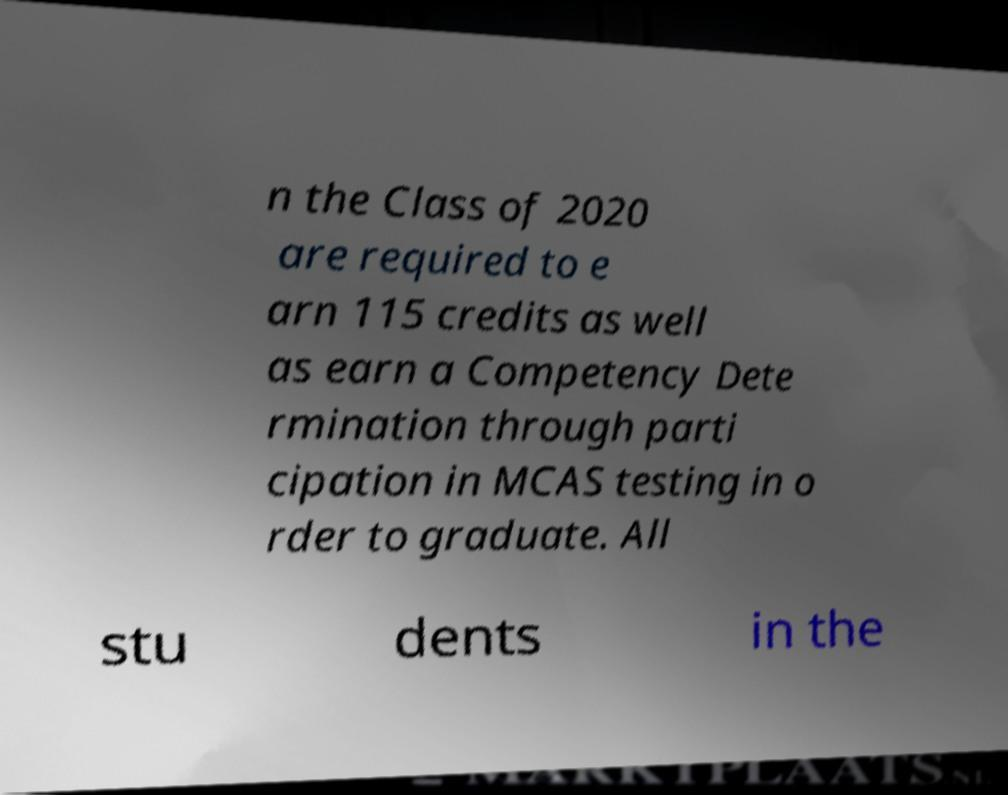Please read and relay the text visible in this image. What does it say? n the Class of 2020 are required to e arn 115 credits as well as earn a Competency Dete rmination through parti cipation in MCAS testing in o rder to graduate. All stu dents in the 